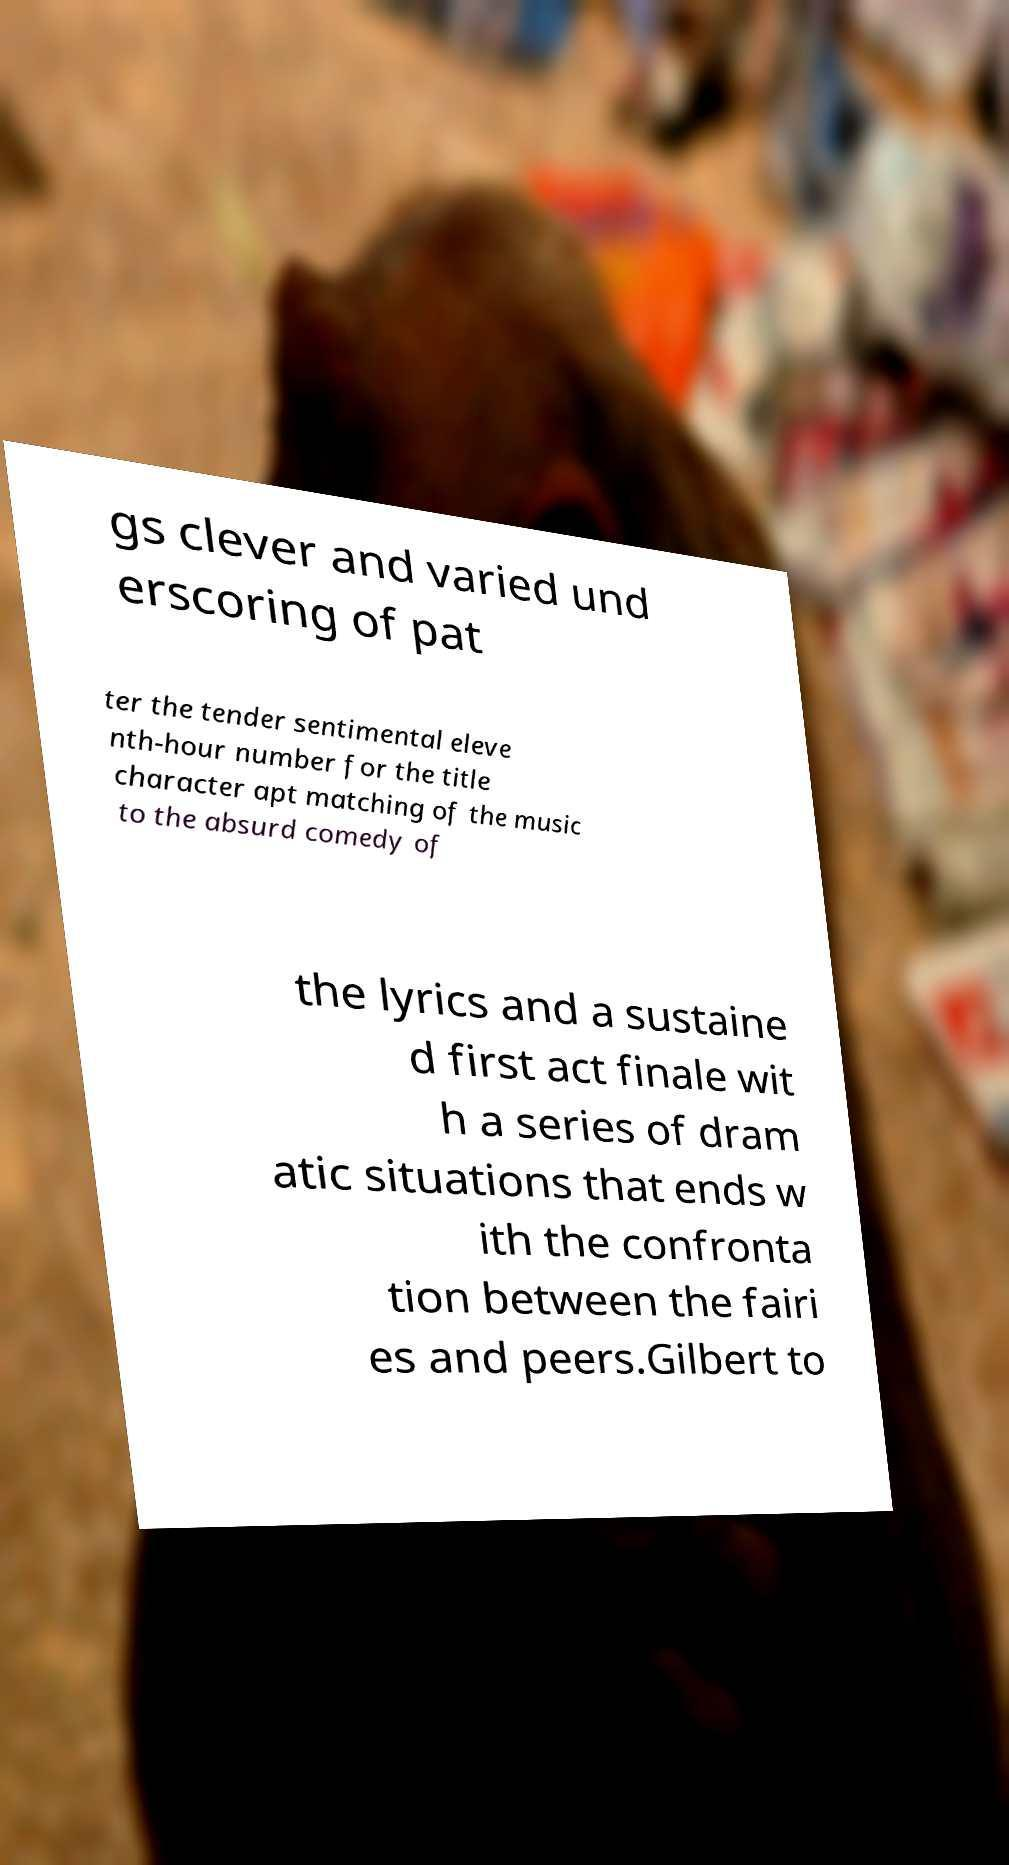Could you assist in decoding the text presented in this image and type it out clearly? gs clever and varied und erscoring of pat ter the tender sentimental eleve nth-hour number for the title character apt matching of the music to the absurd comedy of the lyrics and a sustaine d first act finale wit h a series of dram atic situations that ends w ith the confronta tion between the fairi es and peers.Gilbert to 